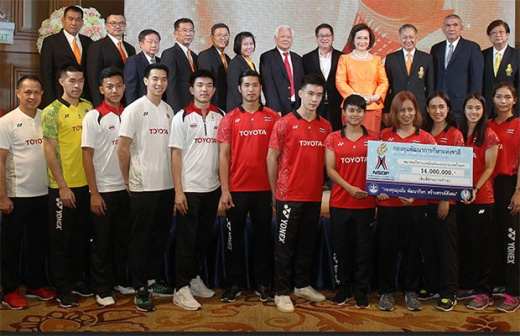What kind of event do you think this is? Based on the image, this seems to be a ceremonial event, possibly a sponsorship announcement or donation ceremony. The presence of individuals in sports uniforms suggests that they may be athletes or members of a sports team, and the large check indicates a significant monetary contribution, likely from the Toyota company. 